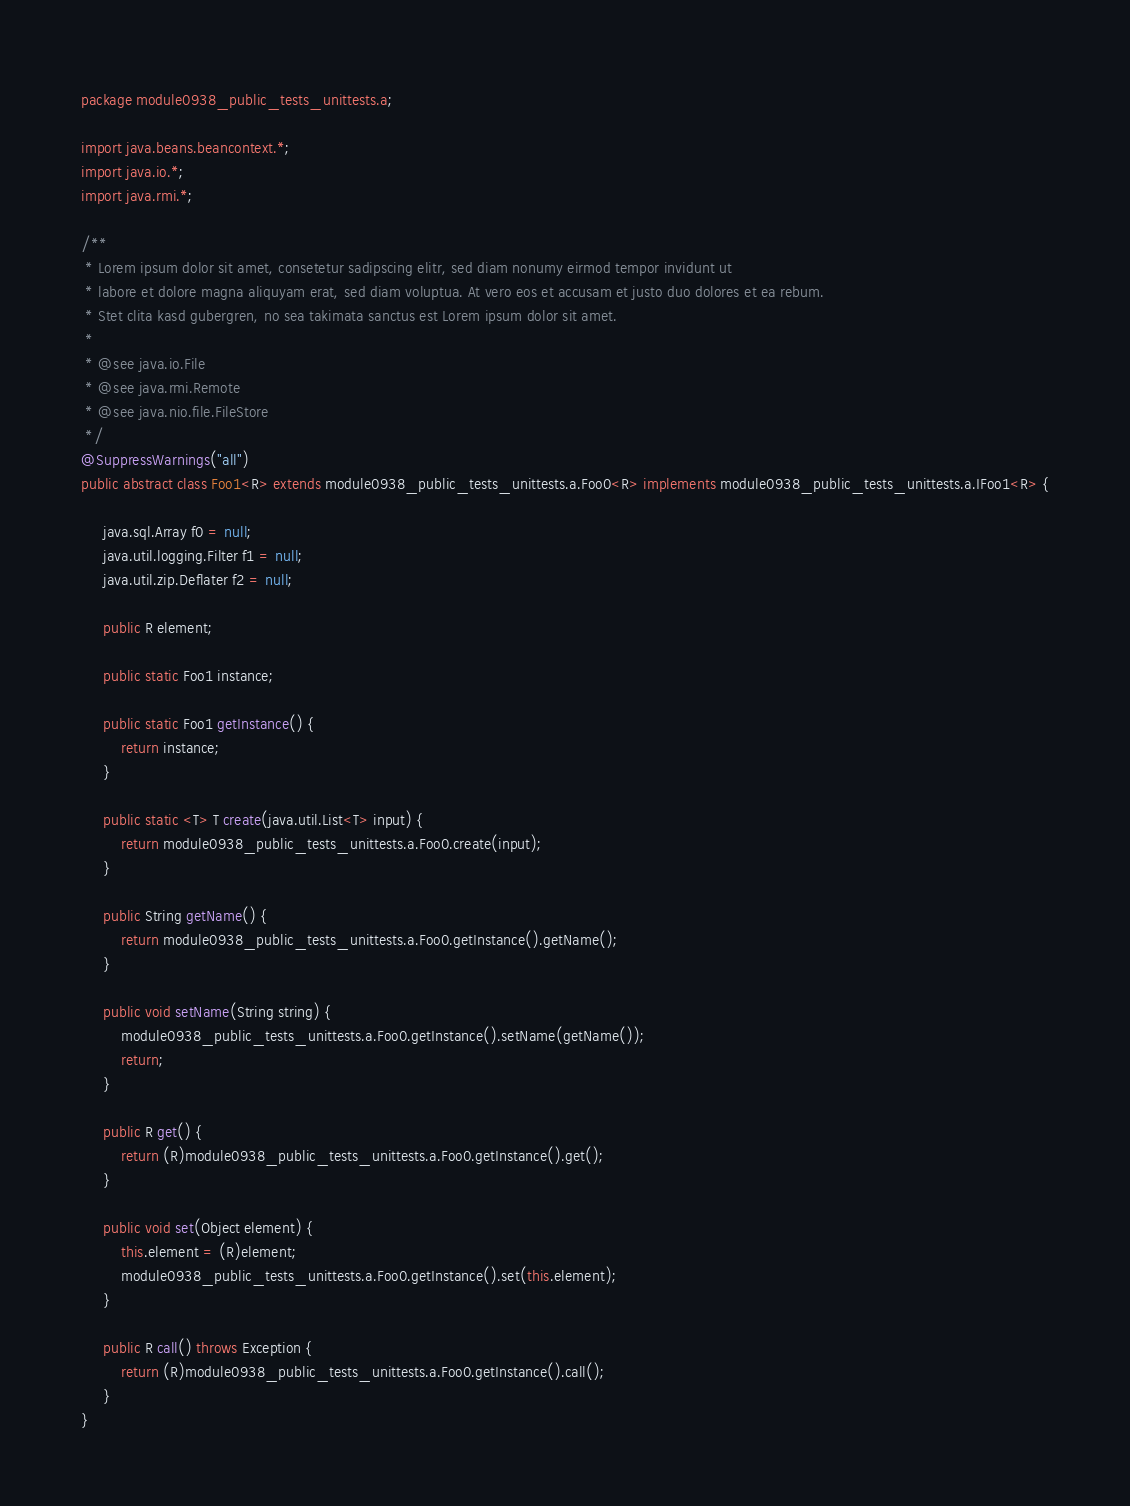Convert code to text. <code><loc_0><loc_0><loc_500><loc_500><_Java_>package module0938_public_tests_unittests.a;

import java.beans.beancontext.*;
import java.io.*;
import java.rmi.*;

/**
 * Lorem ipsum dolor sit amet, consetetur sadipscing elitr, sed diam nonumy eirmod tempor invidunt ut 
 * labore et dolore magna aliquyam erat, sed diam voluptua. At vero eos et accusam et justo duo dolores et ea rebum. 
 * Stet clita kasd gubergren, no sea takimata sanctus est Lorem ipsum dolor sit amet. 
 *
 * @see java.io.File
 * @see java.rmi.Remote
 * @see java.nio.file.FileStore
 */
@SuppressWarnings("all")
public abstract class Foo1<R> extends module0938_public_tests_unittests.a.Foo0<R> implements module0938_public_tests_unittests.a.IFoo1<R> {

	 java.sql.Array f0 = null;
	 java.util.logging.Filter f1 = null;
	 java.util.zip.Deflater f2 = null;

	 public R element;

	 public static Foo1 instance;

	 public static Foo1 getInstance() {
	 	 return instance;
	 }

	 public static <T> T create(java.util.List<T> input) {
	 	 return module0938_public_tests_unittests.a.Foo0.create(input);
	 }

	 public String getName() {
	 	 return module0938_public_tests_unittests.a.Foo0.getInstance().getName();
	 }

	 public void setName(String string) {
	 	 module0938_public_tests_unittests.a.Foo0.getInstance().setName(getName());
	 	 return;
	 }

	 public R get() {
	 	 return (R)module0938_public_tests_unittests.a.Foo0.getInstance().get();
	 }

	 public void set(Object element) {
	 	 this.element = (R)element;
	 	 module0938_public_tests_unittests.a.Foo0.getInstance().set(this.element);
	 }

	 public R call() throws Exception {
	 	 return (R)module0938_public_tests_unittests.a.Foo0.getInstance().call();
	 }
}
</code> 